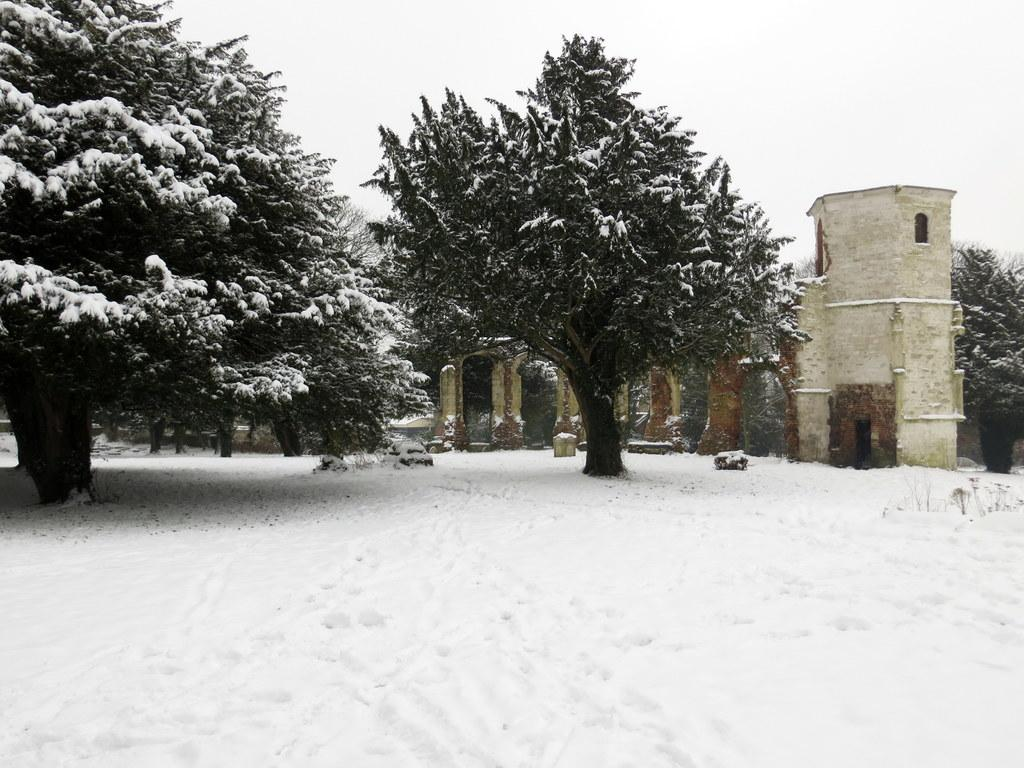What type of structure is present in the image? There is a building in the image. What natural elements can be seen in the image? There are trees and snow visible in the image. What part of the environment is visible in the image? The sky is visible in the image. What type of steel is used to construct the daughter in the image? There is no daughter present in the image, and therefore no steel construction can be observed. 